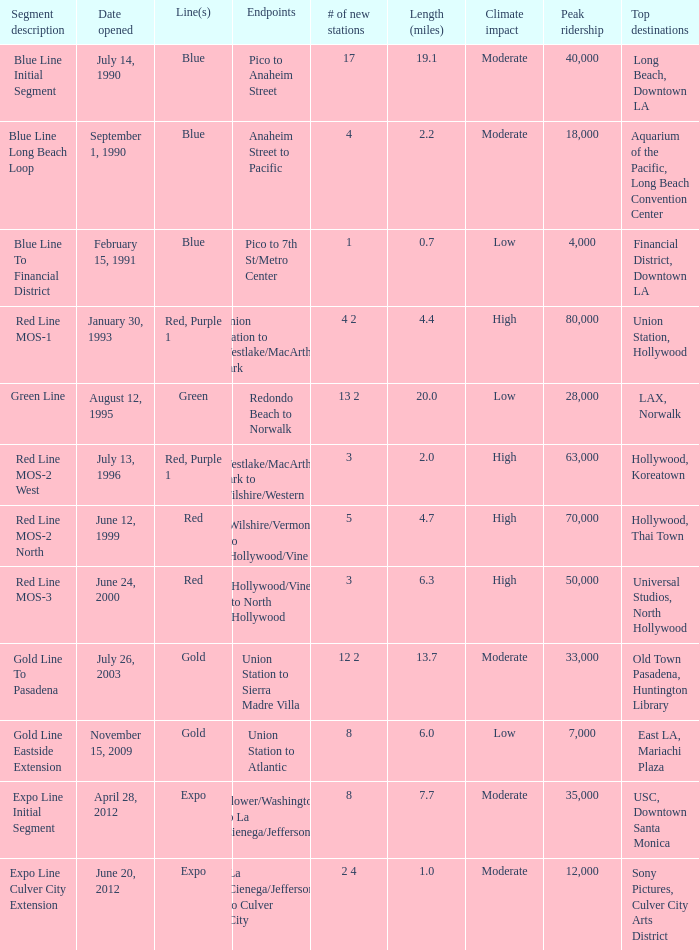What date of segment description red line mos-2 north open? June 12, 1999. 